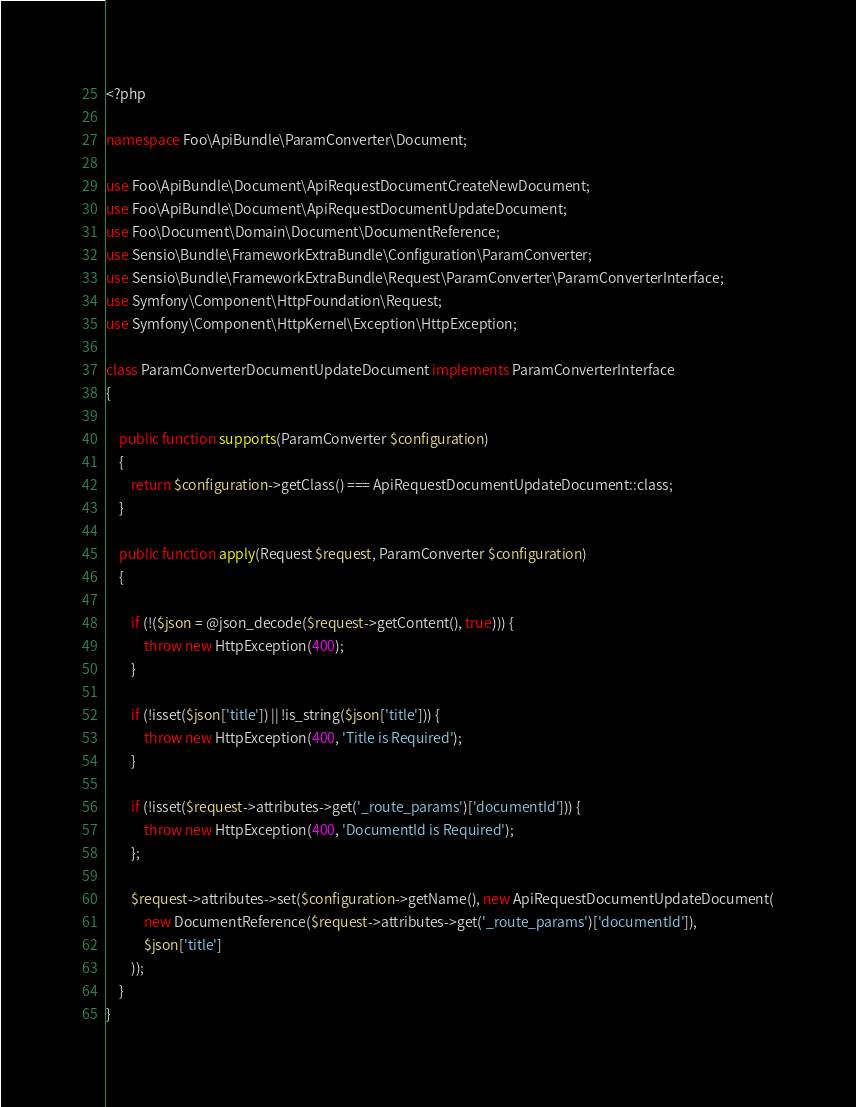Convert code to text. <code><loc_0><loc_0><loc_500><loc_500><_PHP_><?php

namespace Foo\ApiBundle\ParamConverter\Document;

use Foo\ApiBundle\Document\ApiRequestDocumentCreateNewDocument;
use Foo\ApiBundle\Document\ApiRequestDocumentUpdateDocument;
use Foo\Document\Domain\Document\DocumentReference;
use Sensio\Bundle\FrameworkExtraBundle\Configuration\ParamConverter;
use Sensio\Bundle\FrameworkExtraBundle\Request\ParamConverter\ParamConverterInterface;
use Symfony\Component\HttpFoundation\Request;
use Symfony\Component\HttpKernel\Exception\HttpException;

class ParamConverterDocumentUpdateDocument implements ParamConverterInterface
{

    public function supports(ParamConverter $configuration)
    {
        return $configuration->getClass() === ApiRequestDocumentUpdateDocument::class;
    }

    public function apply(Request $request, ParamConverter $configuration)
    {

        if (!($json = @json_decode($request->getContent(), true))) {
            throw new HttpException(400);
        }

        if (!isset($json['title']) || !is_string($json['title'])) {
            throw new HttpException(400, 'Title is Required');
        }

        if (!isset($request->attributes->get('_route_params')['documentId'])) {
            throw new HttpException(400, 'DocumentId is Required');
        };

        $request->attributes->set($configuration->getName(), new ApiRequestDocumentUpdateDocument(
            new DocumentReference($request->attributes->get('_route_params')['documentId']),
            $json['title']
        ));
    }
}</code> 